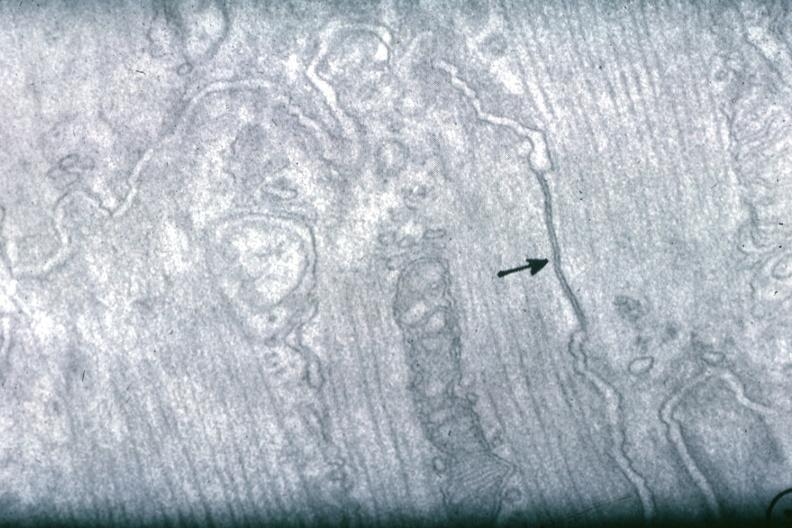what is present?
Answer the question using a single word or phrase. Myocardium 